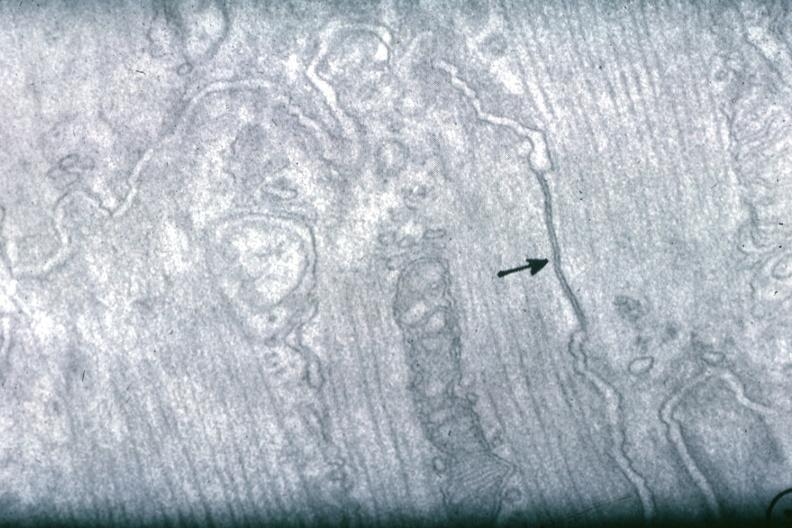what is present?
Answer the question using a single word or phrase. Myocardium 